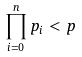<formula> <loc_0><loc_0><loc_500><loc_500>\prod _ { i = 0 } ^ { n } p _ { i } < p</formula> 